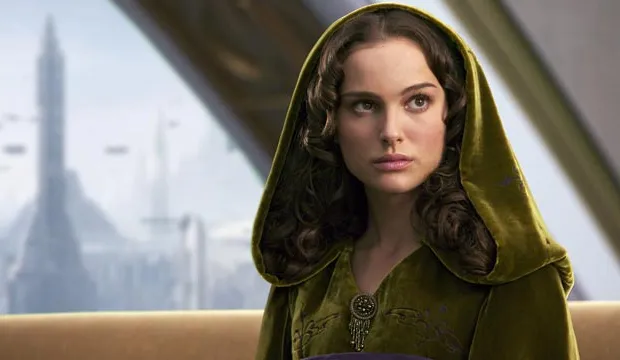Explain the visual content of the image in great detail. The image portrays a woman, draped in an elegant green velvet cloak with a hood, which gives her a regal and mysterious aura. The cloak is secured at her neck with an intricate golden brooch, reflecting her apparent status or significance. Her hair is styled in soft curls that gently frame her delicate features, enhancing her contemplative expression as she gazes to the side, possibly reflecting on a weighty decision. The setting is a futuristic cityscape visible through a large window, featuring soaring skyscrapers and flying vehicles, suggesting an advanced, otherworldly civilization. The overall composition of the image, combining the character's serene, thoughtful demeanor and the dynamic city in the background, hints at a narrative filled with intrigue and complexity, set in a universe where tradition and futuristic technology intersect. 